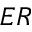Convert formula to latex. <formula><loc_0><loc_0><loc_500><loc_500>E R</formula> 